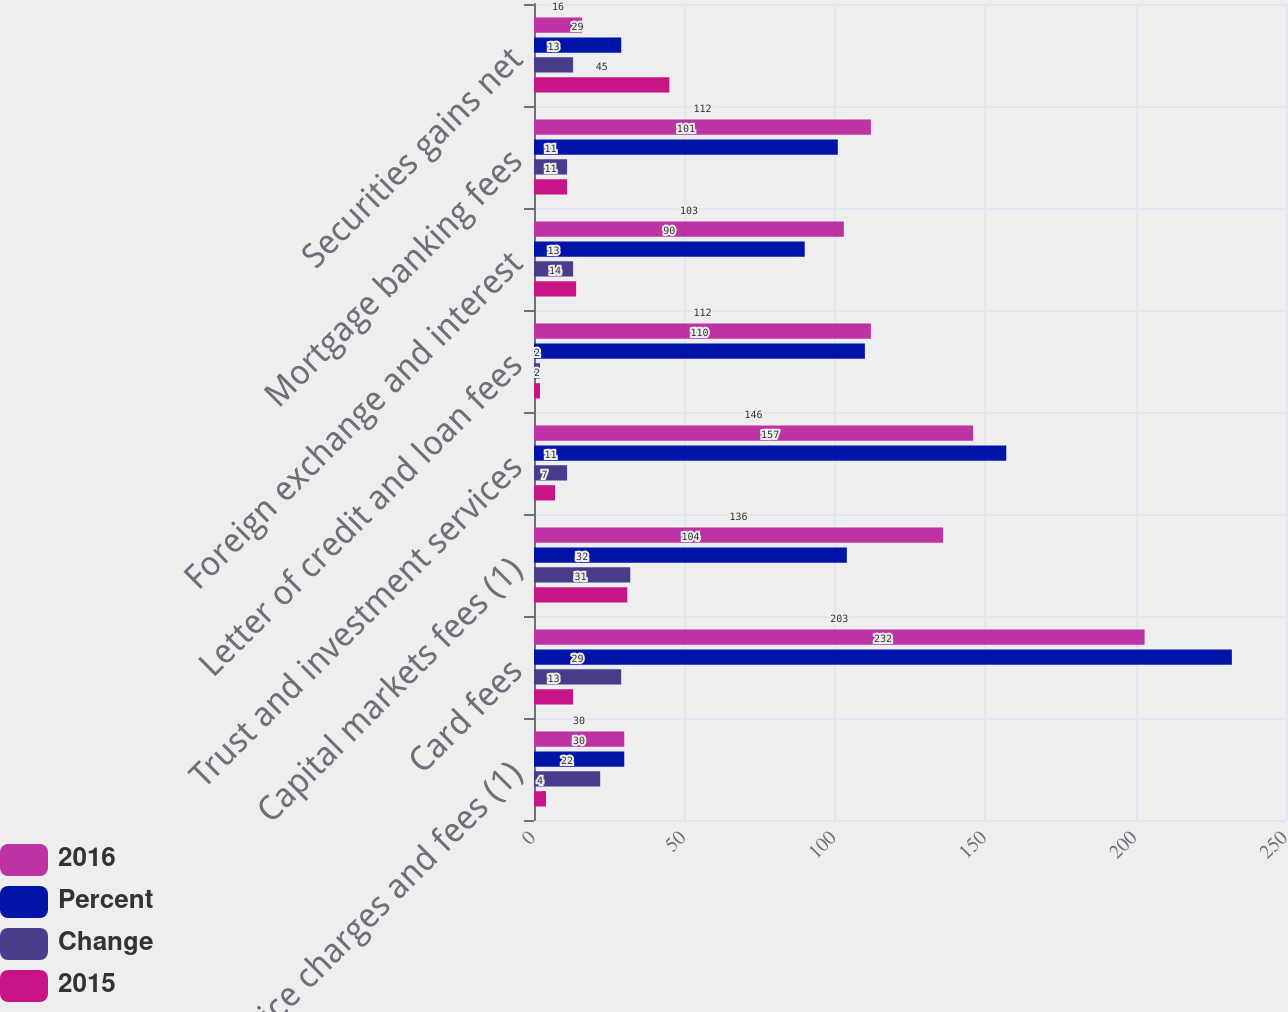Convert chart. <chart><loc_0><loc_0><loc_500><loc_500><stacked_bar_chart><ecel><fcel>Service charges and fees (1)<fcel>Card fees<fcel>Capital markets fees (1)<fcel>Trust and investment services<fcel>Letter of credit and loan fees<fcel>Foreign exchange and interest<fcel>Mortgage banking fees<fcel>Securities gains net<nl><fcel>2016<fcel>30<fcel>203<fcel>136<fcel>146<fcel>112<fcel>103<fcel>112<fcel>16<nl><fcel>Percent<fcel>30<fcel>232<fcel>104<fcel>157<fcel>110<fcel>90<fcel>101<fcel>29<nl><fcel>Change<fcel>22<fcel>29<fcel>32<fcel>11<fcel>2<fcel>13<fcel>11<fcel>13<nl><fcel>2015<fcel>4<fcel>13<fcel>31<fcel>7<fcel>2<fcel>14<fcel>11<fcel>45<nl></chart> 